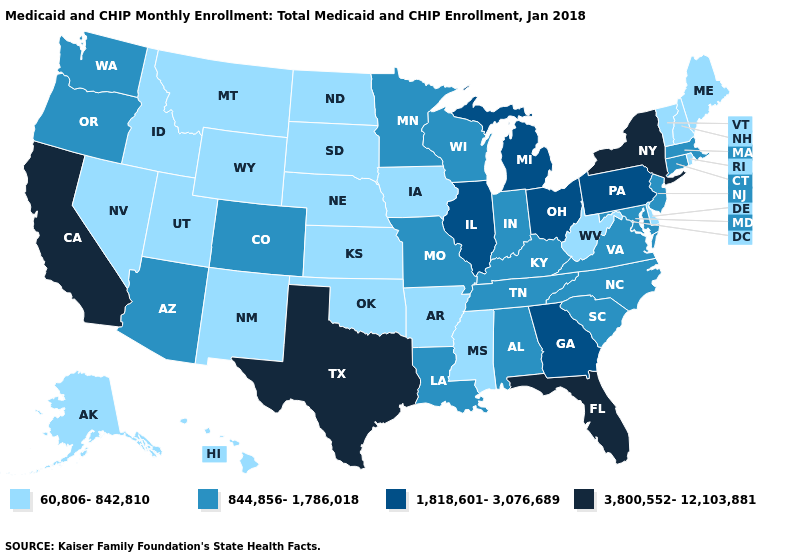Name the states that have a value in the range 3,800,552-12,103,881?
Quick response, please. California, Florida, New York, Texas. Name the states that have a value in the range 1,818,601-3,076,689?
Quick response, please. Georgia, Illinois, Michigan, Ohio, Pennsylvania. What is the value of Arkansas?
Answer briefly. 60,806-842,810. What is the lowest value in the USA?
Answer briefly. 60,806-842,810. How many symbols are there in the legend?
Concise answer only. 4. Which states hav the highest value in the West?
Give a very brief answer. California. What is the value of Illinois?
Answer briefly. 1,818,601-3,076,689. Among the states that border South Dakota , which have the lowest value?
Give a very brief answer. Iowa, Montana, Nebraska, North Dakota, Wyoming. Does New Jersey have the lowest value in the Northeast?
Concise answer only. No. Name the states that have a value in the range 1,818,601-3,076,689?
Concise answer only. Georgia, Illinois, Michigan, Ohio, Pennsylvania. What is the value of Virginia?
Answer briefly. 844,856-1,786,018. Among the states that border Washington , does Oregon have the lowest value?
Concise answer only. No. What is the value of Iowa?
Concise answer only. 60,806-842,810. What is the value of Arizona?
Concise answer only. 844,856-1,786,018. Which states have the highest value in the USA?
Be succinct. California, Florida, New York, Texas. 